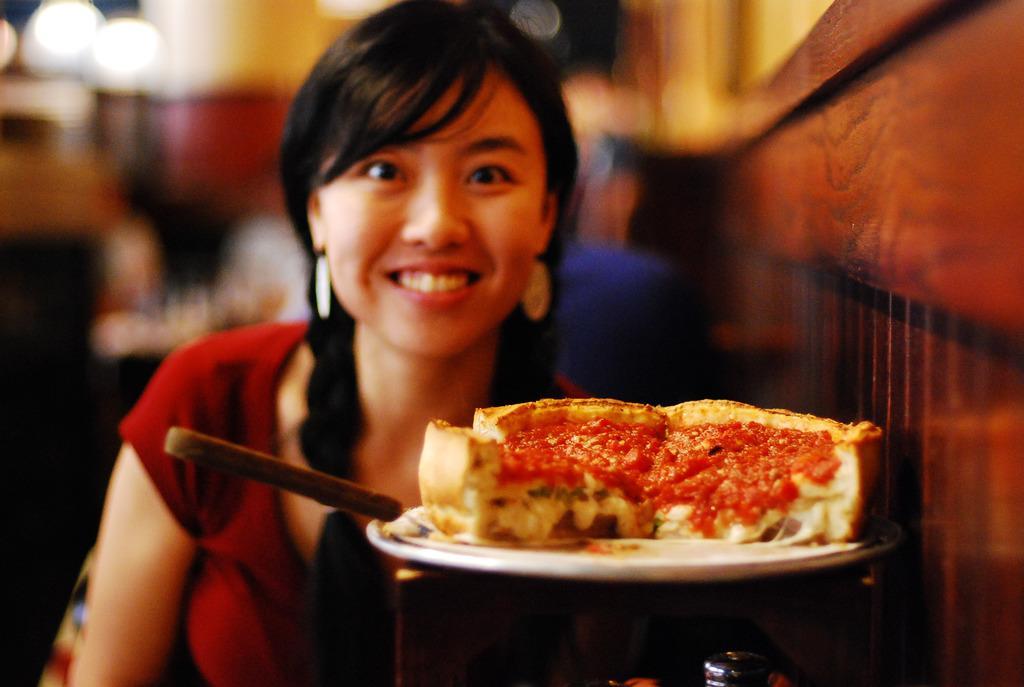How would you summarize this image in a sentence or two? In this picture I can observe a woman. She is smiling. In front of her I can observe some food places in the plate. The background is completely blurred. 